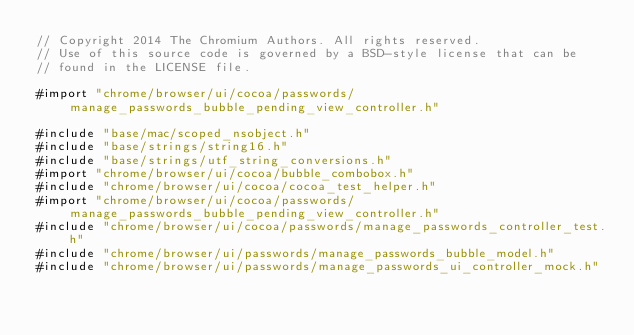<code> <loc_0><loc_0><loc_500><loc_500><_ObjectiveC_>// Copyright 2014 The Chromium Authors. All rights reserved.
// Use of this source code is governed by a BSD-style license that can be
// found in the LICENSE file.

#import "chrome/browser/ui/cocoa/passwords/manage_passwords_bubble_pending_view_controller.h"

#include "base/mac/scoped_nsobject.h"
#include "base/strings/string16.h"
#include "base/strings/utf_string_conversions.h"
#import "chrome/browser/ui/cocoa/bubble_combobox.h"
#include "chrome/browser/ui/cocoa/cocoa_test_helper.h"
#import "chrome/browser/ui/cocoa/passwords/manage_passwords_bubble_pending_view_controller.h"
#include "chrome/browser/ui/cocoa/passwords/manage_passwords_controller_test.h"
#include "chrome/browser/ui/passwords/manage_passwords_bubble_model.h"
#include "chrome/browser/ui/passwords/manage_passwords_ui_controller_mock.h"</code> 